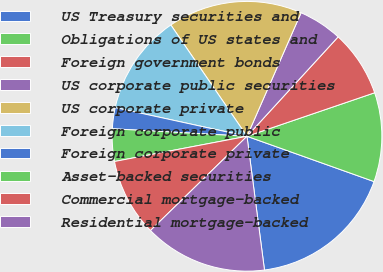Convert chart. <chart><loc_0><loc_0><loc_500><loc_500><pie_chart><fcel>US Treasury securities and<fcel>Obligations of US states and<fcel>Foreign government bonds<fcel>US corporate public securities<fcel>US corporate private<fcel>Foreign corporate public<fcel>Foreign corporate private<fcel>Asset-backed securities<fcel>Commercial mortgage-backed<fcel>Residential mortgage-backed<nl><fcel>17.48%<fcel>10.68%<fcel>7.96%<fcel>5.24%<fcel>16.12%<fcel>12.04%<fcel>2.52%<fcel>3.88%<fcel>9.32%<fcel>14.76%<nl></chart> 